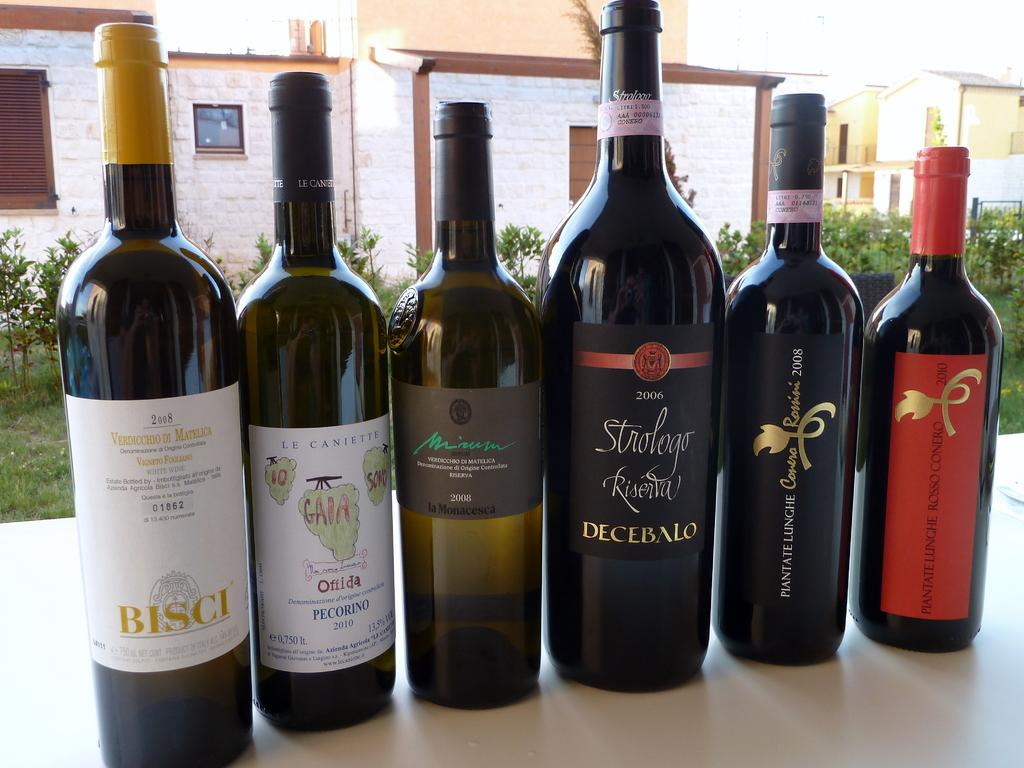<image>
Provide a brief description of the given image. A bottle of 2008 Bisci wine is on the left of 5 other bottles from different companies. 